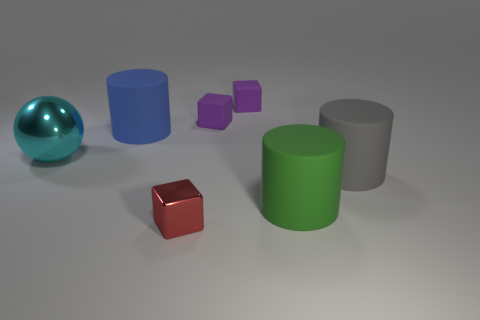Is the number of big gray things that are in front of the large green matte object the same as the number of small brown matte cubes? Yes, the number of large gray cylinders in front of the green cylinder is indeed the same as the number of small brown cubes present in the image; there is one of each. 